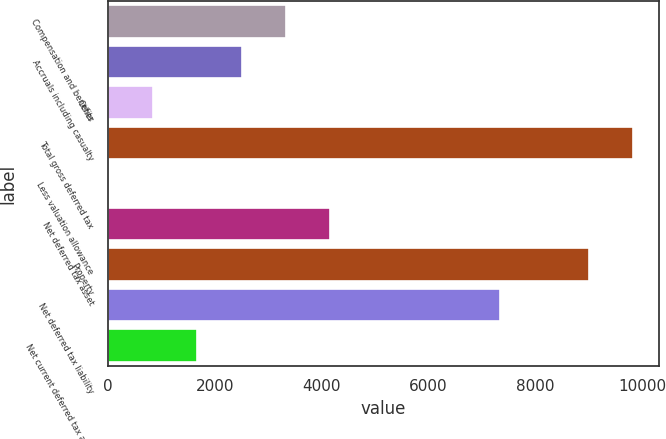<chart> <loc_0><loc_0><loc_500><loc_500><bar_chart><fcel>Compensation and benefits<fcel>Accruals including casualty<fcel>Other<fcel>Total gross deferred tax<fcel>Less valuation allowance<fcel>Net deferred tax asset<fcel>Property<fcel>Net deferred tax liability<fcel>Net current deferred tax asset<nl><fcel>3323.8<fcel>2497.6<fcel>845.2<fcel>9821.6<fcel>19<fcel>4150<fcel>8995.4<fcel>7343<fcel>1671.4<nl></chart> 